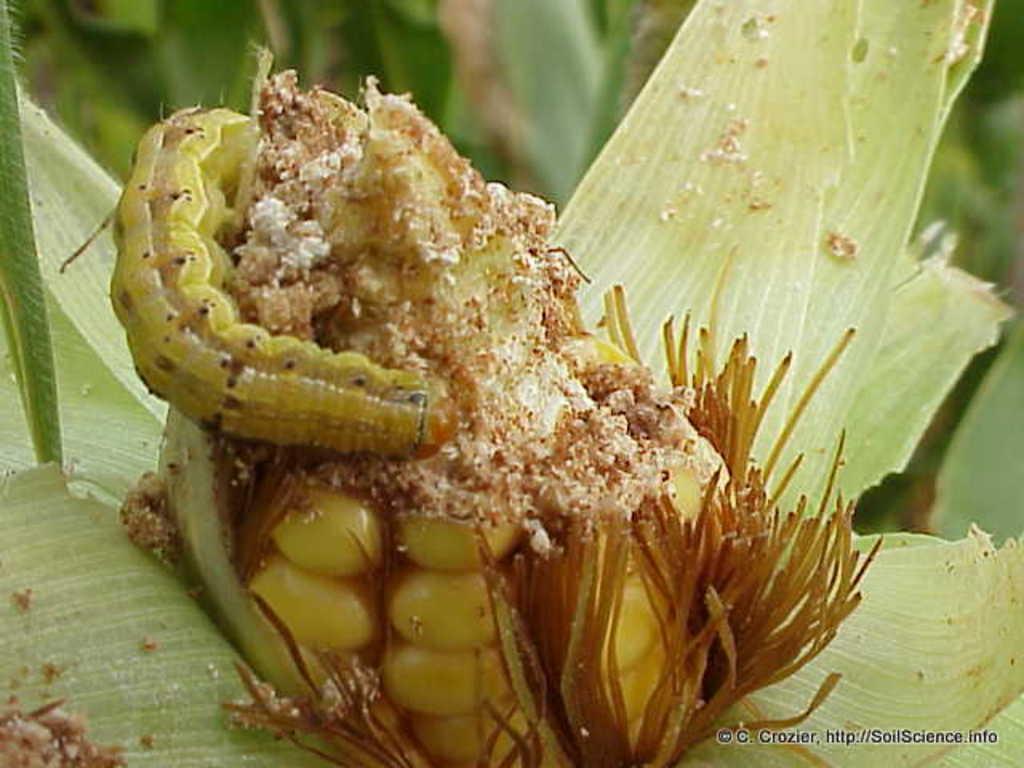In one or two sentences, can you explain what this image depicts? In this image I can see an insect on the corn. In the background I can see many trees. I can see an insect is in green and brown color. 